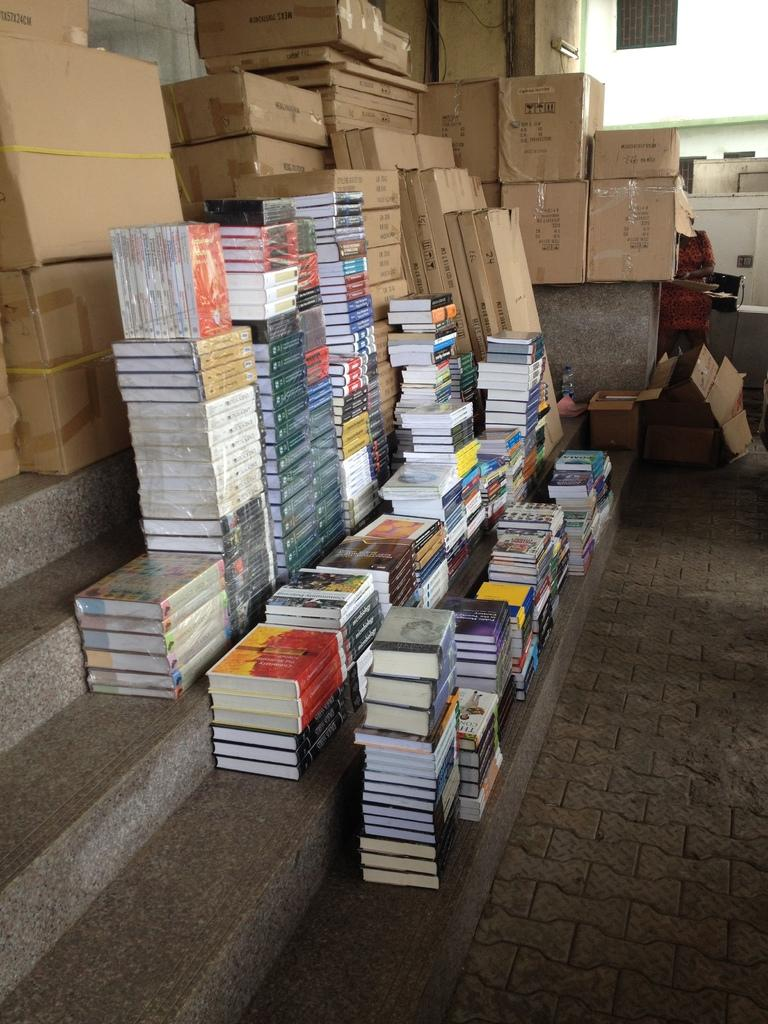What objects are placed on the steps in the image? There are books on the steps in the image. What can be seen at the top of the image? There are boxes at the top of the image. What type of stocking is hanging from the boxes in the image? There is no stocking present in the image. Can you see any harbors or boats in the image? There is no harbor or boat depicted in the image. 